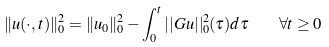Convert formula to latex. <formula><loc_0><loc_0><loc_500><loc_500>\| u ( \cdot , t ) \| _ { 0 } ^ { 2 } = \| u _ { 0 } \| _ { 0 } ^ { 2 } - \int ^ { t } _ { 0 } | | G u | | _ { 0 } ^ { 2 } ( \tau ) d \tau \quad \forall t \geq 0</formula> 